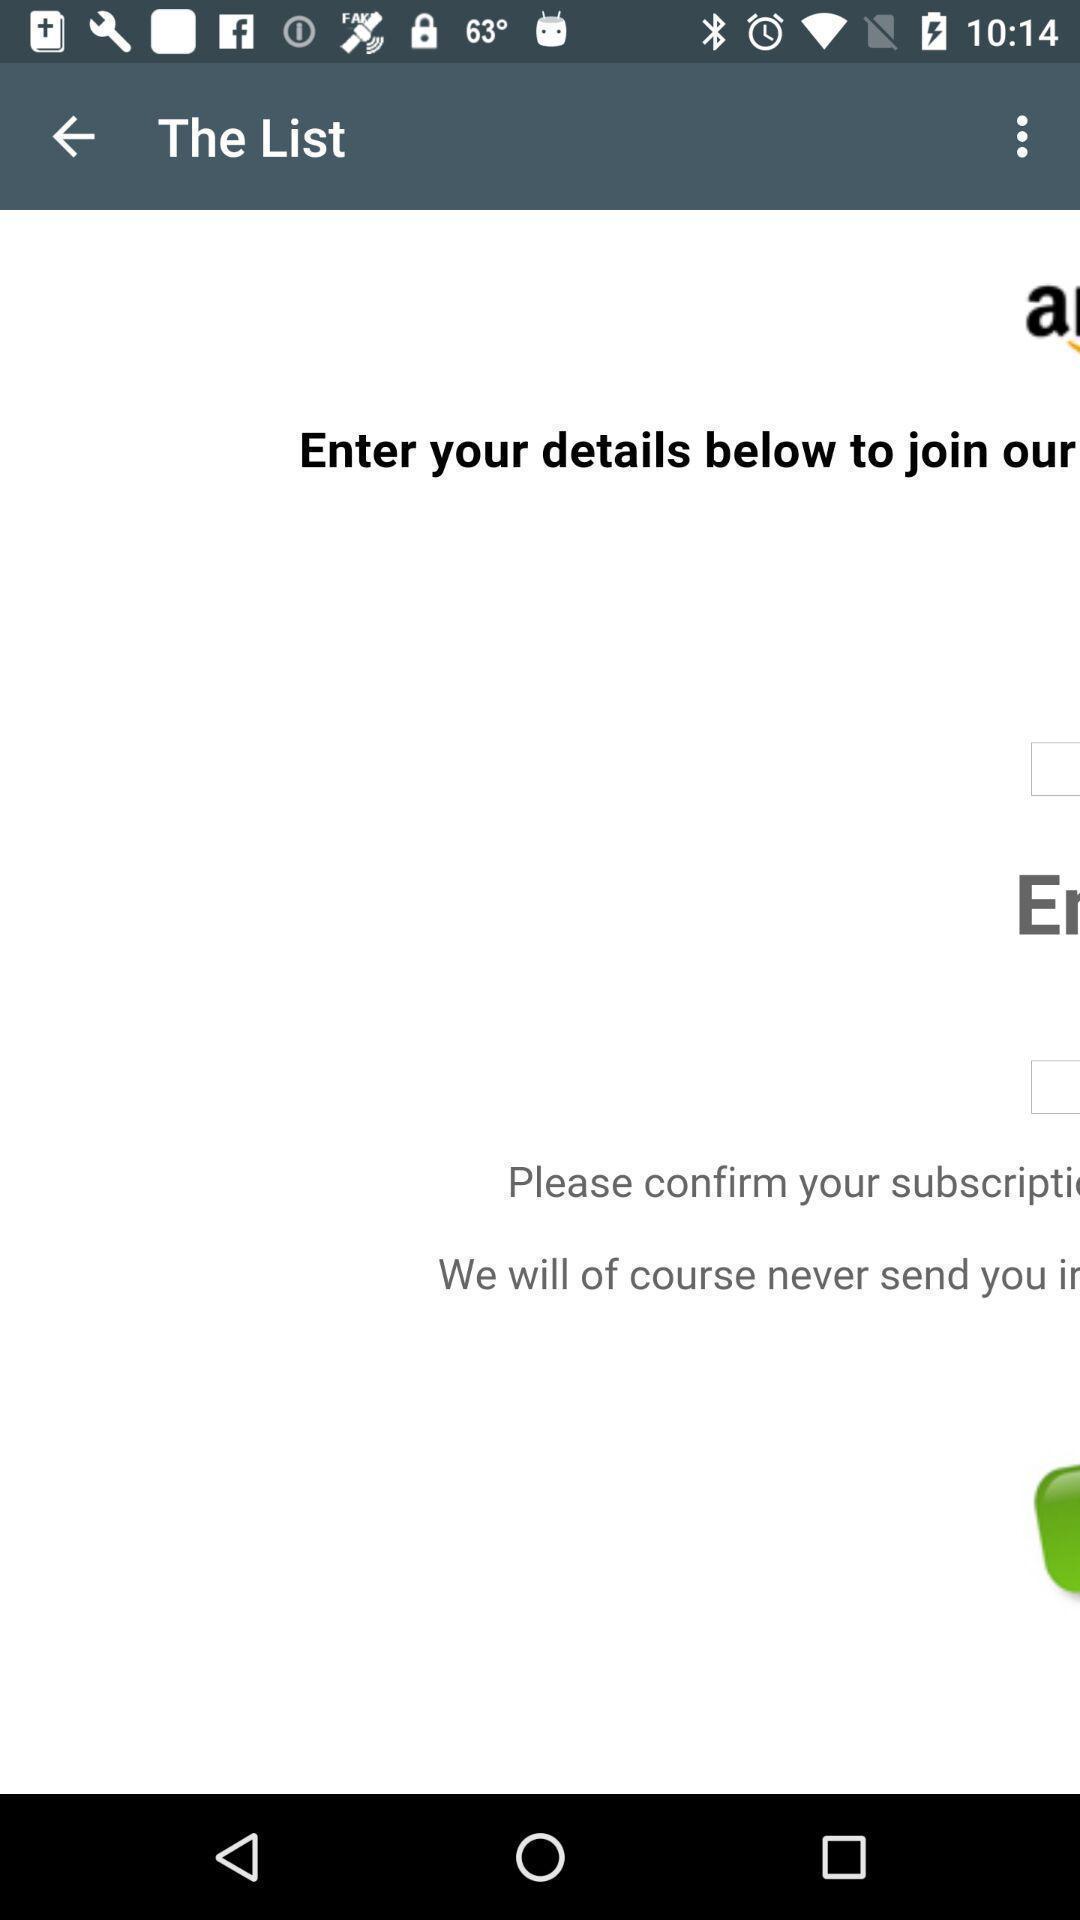Describe the visual elements of this screenshot. Screen shows list details in a shopping application. 